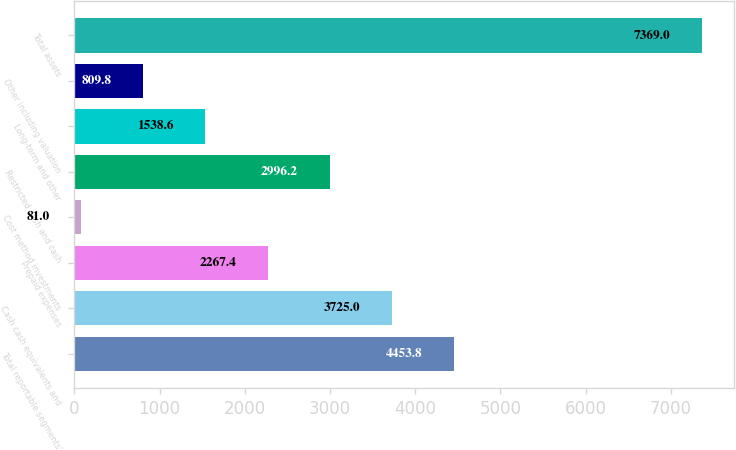Convert chart to OTSL. <chart><loc_0><loc_0><loc_500><loc_500><bar_chart><fcel>Total reportable segments'<fcel>Cash cash equivalents and<fcel>Prepaid expenses<fcel>Cost method investments<fcel>Restricted cash and cash<fcel>Long-term and other<fcel>Other including valuation<fcel>Total assets<nl><fcel>4453.8<fcel>3725<fcel>2267.4<fcel>81<fcel>2996.2<fcel>1538.6<fcel>809.8<fcel>7369<nl></chart> 